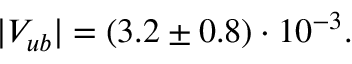<formula> <loc_0><loc_0><loc_500><loc_500>| V _ { u b } | = ( 3 . 2 \pm 0 . 8 ) \cdot 1 0 ^ { - 3 } .</formula> 